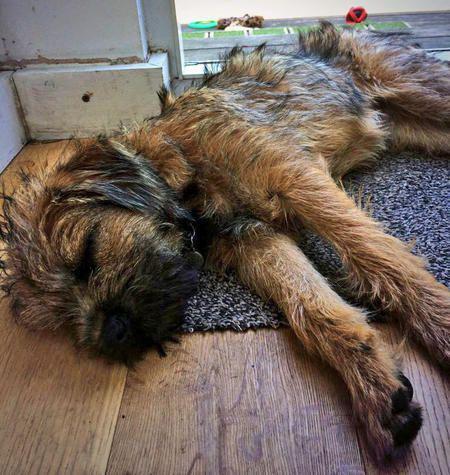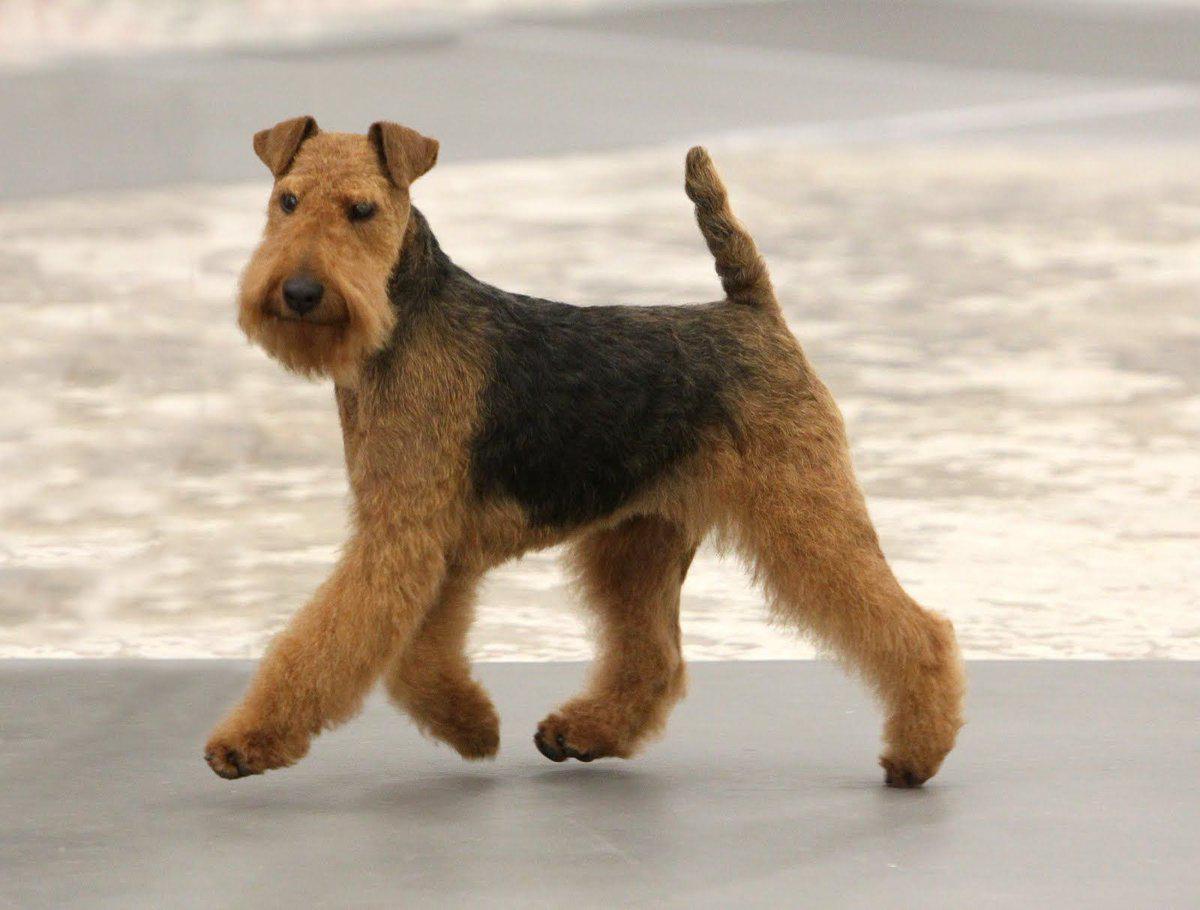The first image is the image on the left, the second image is the image on the right. For the images shown, is this caption "The left and right image contains the same number of dogs with at least one laying down." true? Answer yes or no. Yes. The first image is the image on the left, the second image is the image on the right. Considering the images on both sides, is "The left image shows one dog with a rightward turned body standing on all fours, and the right image shows a dog looking leftward." valid? Answer yes or no. No. 